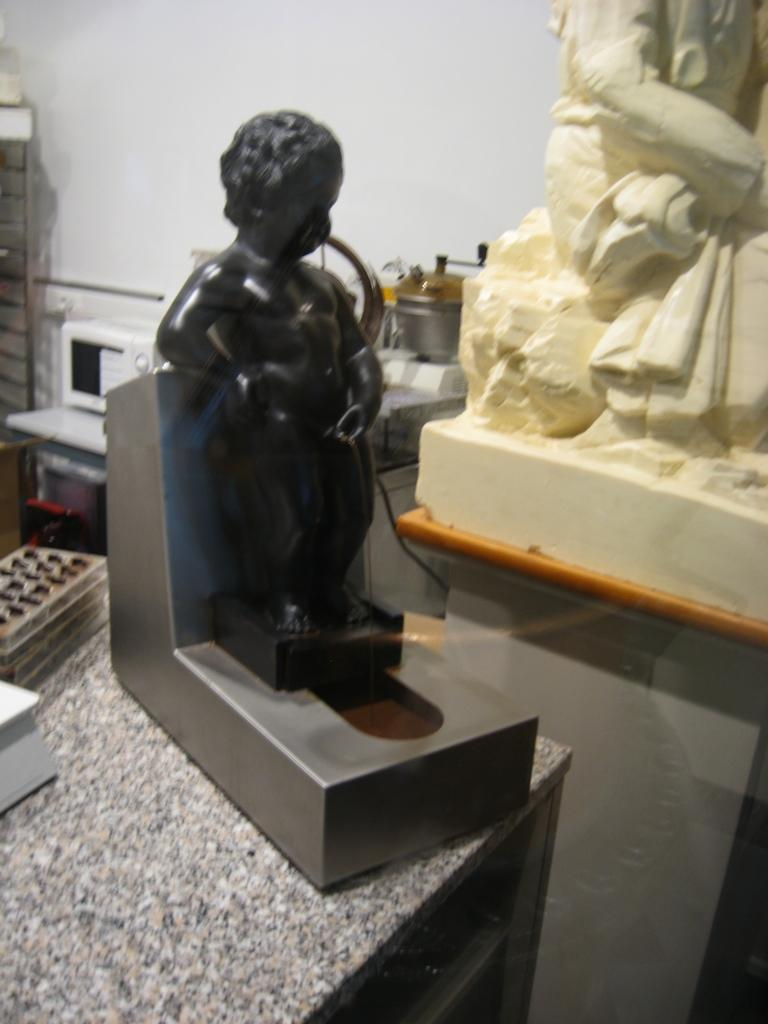What type of furniture is present in the image? There are tables in the image. What type of decorative objects can be seen in the image? There are statues in the image. What color is the wall visible in the image? There is a white-colored wall in the image. Can you tell me how many cherries are on the man's baseball cap in the image? There is no man or baseball cap present in the image, so it is not possible to determine how many cherries might be on a cap. 